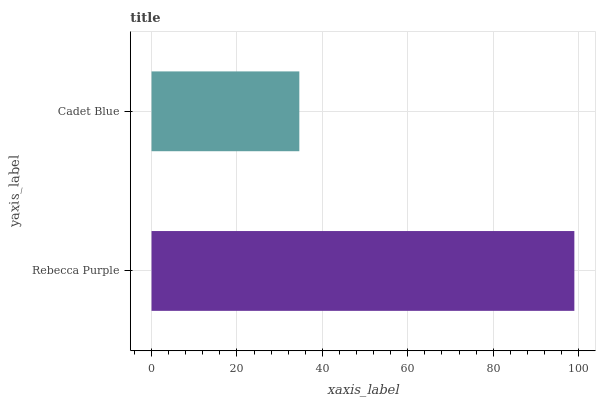Is Cadet Blue the minimum?
Answer yes or no. Yes. Is Rebecca Purple the maximum?
Answer yes or no. Yes. Is Cadet Blue the maximum?
Answer yes or no. No. Is Rebecca Purple greater than Cadet Blue?
Answer yes or no. Yes. Is Cadet Blue less than Rebecca Purple?
Answer yes or no. Yes. Is Cadet Blue greater than Rebecca Purple?
Answer yes or no. No. Is Rebecca Purple less than Cadet Blue?
Answer yes or no. No. Is Rebecca Purple the high median?
Answer yes or no. Yes. Is Cadet Blue the low median?
Answer yes or no. Yes. Is Cadet Blue the high median?
Answer yes or no. No. Is Rebecca Purple the low median?
Answer yes or no. No. 